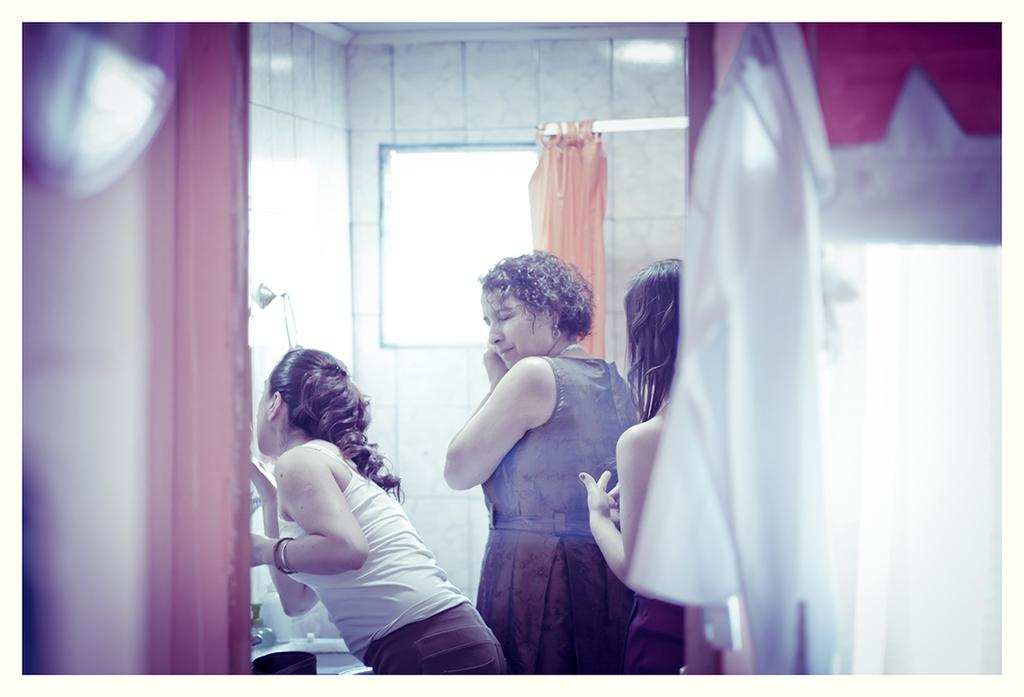What type of window treatment is visible in the image? There are curtains in the image. What is the primary architectural feature in the image? There is a window in the image. What type of background is present in the image? There is a wall in the image. How many women are present in the image? There are women in the image. What type of objects can be seen in the image? There are objects in the image. Where is the tap and wash basin located in the image? There is a tap and wash basin in the bottom left corner of the image. What is the color of the black object in the bottom left corner of the image? There is a black object in the bottom left corner of the image. What number is written on the head of the woman in the image? There is no number written on the head of the woman in the image. What type of discovery is being made in the image? There is no discovery being made in the image; it is a scene with curtains, a window, a wall, women, objects, a tap, a wash basin, and a black object. 